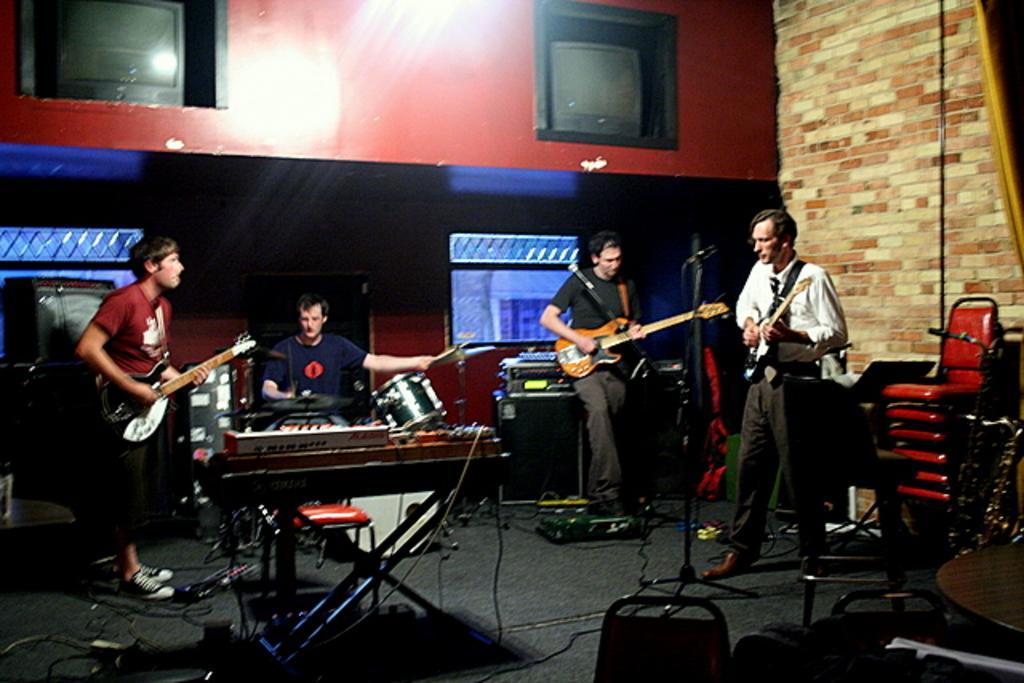Could you give a brief overview of what you see in this image? In this image I can see few people are standing and holding guitars. I can also see a man is sitting next to a drum set. 